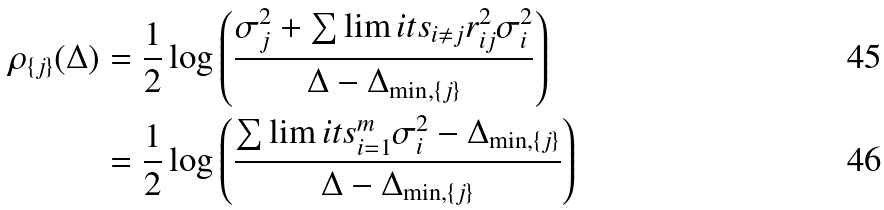<formula> <loc_0><loc_0><loc_500><loc_500>\rho _ { \{ j \} } ( \Delta ) & = \frac { 1 } { 2 } \log \left ( \frac { \sigma _ { j } ^ { 2 } + \sum \lim i t s _ { i \neq j } r _ { i j } ^ { 2 } \sigma _ { i } ^ { 2 } } { \Delta - \Delta _ { \min , \{ j \} } } \right ) \\ & = \frac { 1 } { 2 } \log \left ( \frac { \sum \lim i t s _ { i = 1 } ^ { m } \sigma _ { i } ^ { 2 } - \Delta _ { \min , \{ j \} } } { \Delta - \Delta _ { \min , \{ j \} } } \right )</formula> 